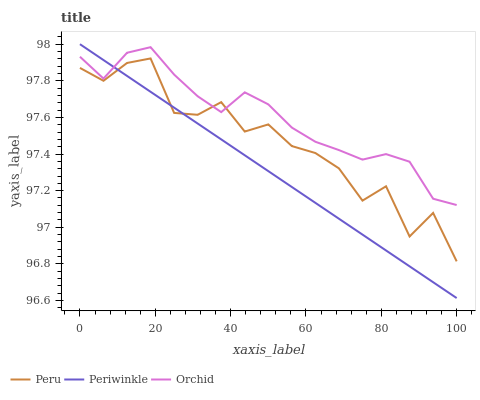Does Periwinkle have the minimum area under the curve?
Answer yes or no. Yes. Does Orchid have the maximum area under the curve?
Answer yes or no. Yes. Does Peru have the minimum area under the curve?
Answer yes or no. No. Does Peru have the maximum area under the curve?
Answer yes or no. No. Is Periwinkle the smoothest?
Answer yes or no. Yes. Is Peru the roughest?
Answer yes or no. Yes. Is Orchid the smoothest?
Answer yes or no. No. Is Orchid the roughest?
Answer yes or no. No. Does Periwinkle have the lowest value?
Answer yes or no. Yes. Does Peru have the lowest value?
Answer yes or no. No. Does Periwinkle have the highest value?
Answer yes or no. Yes. Does Orchid have the highest value?
Answer yes or no. No. Does Orchid intersect Periwinkle?
Answer yes or no. Yes. Is Orchid less than Periwinkle?
Answer yes or no. No. Is Orchid greater than Periwinkle?
Answer yes or no. No. 